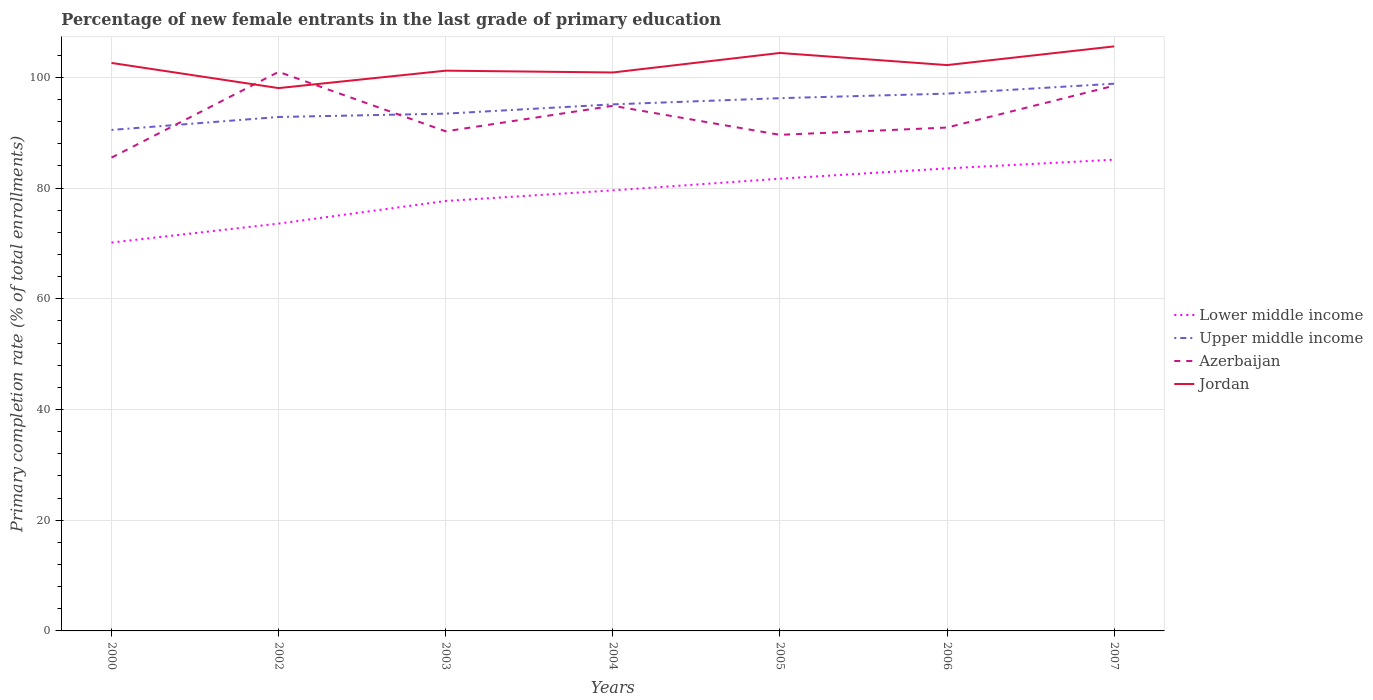Is the number of lines equal to the number of legend labels?
Your response must be concise. Yes. Across all years, what is the maximum percentage of new female entrants in Jordan?
Your response must be concise. 98.06. What is the total percentage of new female entrants in Jordan in the graph?
Provide a short and direct response. -4.16. What is the difference between the highest and the second highest percentage of new female entrants in Jordan?
Keep it short and to the point. 7.54. What is the difference between the highest and the lowest percentage of new female entrants in Jordan?
Your response must be concise. 4. Is the percentage of new female entrants in Lower middle income strictly greater than the percentage of new female entrants in Upper middle income over the years?
Your answer should be compact. Yes. How many lines are there?
Provide a short and direct response. 4. What is the difference between two consecutive major ticks on the Y-axis?
Give a very brief answer. 20. Are the values on the major ticks of Y-axis written in scientific E-notation?
Make the answer very short. No. Where does the legend appear in the graph?
Ensure brevity in your answer.  Center right. How are the legend labels stacked?
Your answer should be compact. Vertical. What is the title of the graph?
Your response must be concise. Percentage of new female entrants in the last grade of primary education. What is the label or title of the Y-axis?
Make the answer very short. Primary completion rate (% of total enrollments). What is the Primary completion rate (% of total enrollments) of Lower middle income in 2000?
Ensure brevity in your answer.  70.16. What is the Primary completion rate (% of total enrollments) of Upper middle income in 2000?
Offer a very short reply. 90.5. What is the Primary completion rate (% of total enrollments) in Azerbaijan in 2000?
Your answer should be compact. 85.5. What is the Primary completion rate (% of total enrollments) of Jordan in 2000?
Give a very brief answer. 102.6. What is the Primary completion rate (% of total enrollments) of Lower middle income in 2002?
Ensure brevity in your answer.  73.58. What is the Primary completion rate (% of total enrollments) of Upper middle income in 2002?
Your response must be concise. 92.84. What is the Primary completion rate (% of total enrollments) of Azerbaijan in 2002?
Your answer should be compact. 100.99. What is the Primary completion rate (% of total enrollments) of Jordan in 2002?
Provide a short and direct response. 98.06. What is the Primary completion rate (% of total enrollments) in Lower middle income in 2003?
Give a very brief answer. 77.67. What is the Primary completion rate (% of total enrollments) in Upper middle income in 2003?
Make the answer very short. 93.44. What is the Primary completion rate (% of total enrollments) of Azerbaijan in 2003?
Offer a terse response. 90.25. What is the Primary completion rate (% of total enrollments) in Jordan in 2003?
Your answer should be compact. 101.21. What is the Primary completion rate (% of total enrollments) in Lower middle income in 2004?
Give a very brief answer. 79.58. What is the Primary completion rate (% of total enrollments) in Upper middle income in 2004?
Give a very brief answer. 95.12. What is the Primary completion rate (% of total enrollments) in Azerbaijan in 2004?
Make the answer very short. 94.86. What is the Primary completion rate (% of total enrollments) of Jordan in 2004?
Your answer should be very brief. 100.88. What is the Primary completion rate (% of total enrollments) of Lower middle income in 2005?
Make the answer very short. 81.69. What is the Primary completion rate (% of total enrollments) in Upper middle income in 2005?
Your answer should be very brief. 96.24. What is the Primary completion rate (% of total enrollments) of Azerbaijan in 2005?
Your response must be concise. 89.61. What is the Primary completion rate (% of total enrollments) of Jordan in 2005?
Your answer should be compact. 104.4. What is the Primary completion rate (% of total enrollments) in Lower middle income in 2006?
Your answer should be compact. 83.55. What is the Primary completion rate (% of total enrollments) of Upper middle income in 2006?
Offer a very short reply. 97.06. What is the Primary completion rate (% of total enrollments) of Azerbaijan in 2006?
Give a very brief answer. 90.93. What is the Primary completion rate (% of total enrollments) in Jordan in 2006?
Give a very brief answer. 102.21. What is the Primary completion rate (% of total enrollments) of Lower middle income in 2007?
Provide a short and direct response. 85.12. What is the Primary completion rate (% of total enrollments) in Upper middle income in 2007?
Ensure brevity in your answer.  98.85. What is the Primary completion rate (% of total enrollments) in Azerbaijan in 2007?
Your answer should be compact. 98.49. What is the Primary completion rate (% of total enrollments) of Jordan in 2007?
Ensure brevity in your answer.  105.59. Across all years, what is the maximum Primary completion rate (% of total enrollments) in Lower middle income?
Your answer should be compact. 85.12. Across all years, what is the maximum Primary completion rate (% of total enrollments) of Upper middle income?
Your response must be concise. 98.85. Across all years, what is the maximum Primary completion rate (% of total enrollments) of Azerbaijan?
Offer a terse response. 100.99. Across all years, what is the maximum Primary completion rate (% of total enrollments) of Jordan?
Offer a terse response. 105.59. Across all years, what is the minimum Primary completion rate (% of total enrollments) in Lower middle income?
Give a very brief answer. 70.16. Across all years, what is the minimum Primary completion rate (% of total enrollments) in Upper middle income?
Provide a short and direct response. 90.5. Across all years, what is the minimum Primary completion rate (% of total enrollments) in Azerbaijan?
Your answer should be compact. 85.5. Across all years, what is the minimum Primary completion rate (% of total enrollments) of Jordan?
Your response must be concise. 98.06. What is the total Primary completion rate (% of total enrollments) in Lower middle income in the graph?
Your answer should be compact. 551.36. What is the total Primary completion rate (% of total enrollments) of Upper middle income in the graph?
Your response must be concise. 664.05. What is the total Primary completion rate (% of total enrollments) in Azerbaijan in the graph?
Your response must be concise. 650.63. What is the total Primary completion rate (% of total enrollments) in Jordan in the graph?
Provide a succinct answer. 714.95. What is the difference between the Primary completion rate (% of total enrollments) of Lower middle income in 2000 and that in 2002?
Make the answer very short. -3.42. What is the difference between the Primary completion rate (% of total enrollments) in Upper middle income in 2000 and that in 2002?
Your answer should be compact. -2.34. What is the difference between the Primary completion rate (% of total enrollments) in Azerbaijan in 2000 and that in 2002?
Keep it short and to the point. -15.49. What is the difference between the Primary completion rate (% of total enrollments) of Jordan in 2000 and that in 2002?
Your answer should be compact. 4.54. What is the difference between the Primary completion rate (% of total enrollments) in Lower middle income in 2000 and that in 2003?
Provide a short and direct response. -7.51. What is the difference between the Primary completion rate (% of total enrollments) in Upper middle income in 2000 and that in 2003?
Provide a succinct answer. -2.94. What is the difference between the Primary completion rate (% of total enrollments) of Azerbaijan in 2000 and that in 2003?
Ensure brevity in your answer.  -4.75. What is the difference between the Primary completion rate (% of total enrollments) in Jordan in 2000 and that in 2003?
Offer a terse response. 1.4. What is the difference between the Primary completion rate (% of total enrollments) in Lower middle income in 2000 and that in 2004?
Ensure brevity in your answer.  -9.42. What is the difference between the Primary completion rate (% of total enrollments) of Upper middle income in 2000 and that in 2004?
Give a very brief answer. -4.62. What is the difference between the Primary completion rate (% of total enrollments) of Azerbaijan in 2000 and that in 2004?
Your answer should be very brief. -9.36. What is the difference between the Primary completion rate (% of total enrollments) of Jordan in 2000 and that in 2004?
Provide a short and direct response. 1.72. What is the difference between the Primary completion rate (% of total enrollments) in Lower middle income in 2000 and that in 2005?
Keep it short and to the point. -11.53. What is the difference between the Primary completion rate (% of total enrollments) of Upper middle income in 2000 and that in 2005?
Make the answer very short. -5.74. What is the difference between the Primary completion rate (% of total enrollments) of Azerbaijan in 2000 and that in 2005?
Provide a succinct answer. -4.12. What is the difference between the Primary completion rate (% of total enrollments) in Jordan in 2000 and that in 2005?
Offer a very short reply. -1.8. What is the difference between the Primary completion rate (% of total enrollments) in Lower middle income in 2000 and that in 2006?
Ensure brevity in your answer.  -13.39. What is the difference between the Primary completion rate (% of total enrollments) of Upper middle income in 2000 and that in 2006?
Provide a succinct answer. -6.56. What is the difference between the Primary completion rate (% of total enrollments) in Azerbaijan in 2000 and that in 2006?
Provide a succinct answer. -5.43. What is the difference between the Primary completion rate (% of total enrollments) of Jordan in 2000 and that in 2006?
Offer a terse response. 0.39. What is the difference between the Primary completion rate (% of total enrollments) in Lower middle income in 2000 and that in 2007?
Your response must be concise. -14.96. What is the difference between the Primary completion rate (% of total enrollments) of Upper middle income in 2000 and that in 2007?
Your answer should be compact. -8.35. What is the difference between the Primary completion rate (% of total enrollments) in Azerbaijan in 2000 and that in 2007?
Your response must be concise. -12.99. What is the difference between the Primary completion rate (% of total enrollments) in Jordan in 2000 and that in 2007?
Your answer should be compact. -2.99. What is the difference between the Primary completion rate (% of total enrollments) of Lower middle income in 2002 and that in 2003?
Offer a terse response. -4.08. What is the difference between the Primary completion rate (% of total enrollments) in Upper middle income in 2002 and that in 2003?
Make the answer very short. -0.6. What is the difference between the Primary completion rate (% of total enrollments) in Azerbaijan in 2002 and that in 2003?
Give a very brief answer. 10.74. What is the difference between the Primary completion rate (% of total enrollments) of Jordan in 2002 and that in 2003?
Make the answer very short. -3.15. What is the difference between the Primary completion rate (% of total enrollments) in Lower middle income in 2002 and that in 2004?
Your answer should be compact. -6. What is the difference between the Primary completion rate (% of total enrollments) of Upper middle income in 2002 and that in 2004?
Keep it short and to the point. -2.28. What is the difference between the Primary completion rate (% of total enrollments) in Azerbaijan in 2002 and that in 2004?
Make the answer very short. 6.13. What is the difference between the Primary completion rate (% of total enrollments) in Jordan in 2002 and that in 2004?
Offer a terse response. -2.82. What is the difference between the Primary completion rate (% of total enrollments) in Lower middle income in 2002 and that in 2005?
Your answer should be very brief. -8.11. What is the difference between the Primary completion rate (% of total enrollments) in Upper middle income in 2002 and that in 2005?
Give a very brief answer. -3.4. What is the difference between the Primary completion rate (% of total enrollments) of Azerbaijan in 2002 and that in 2005?
Make the answer very short. 11.38. What is the difference between the Primary completion rate (% of total enrollments) in Jordan in 2002 and that in 2005?
Offer a very short reply. -6.35. What is the difference between the Primary completion rate (% of total enrollments) of Lower middle income in 2002 and that in 2006?
Provide a short and direct response. -9.97. What is the difference between the Primary completion rate (% of total enrollments) of Upper middle income in 2002 and that in 2006?
Your answer should be very brief. -4.22. What is the difference between the Primary completion rate (% of total enrollments) in Azerbaijan in 2002 and that in 2006?
Offer a terse response. 10.06. What is the difference between the Primary completion rate (% of total enrollments) of Jordan in 2002 and that in 2006?
Make the answer very short. -4.16. What is the difference between the Primary completion rate (% of total enrollments) of Lower middle income in 2002 and that in 2007?
Provide a short and direct response. -11.54. What is the difference between the Primary completion rate (% of total enrollments) of Upper middle income in 2002 and that in 2007?
Your answer should be compact. -6.01. What is the difference between the Primary completion rate (% of total enrollments) of Azerbaijan in 2002 and that in 2007?
Provide a short and direct response. 2.5. What is the difference between the Primary completion rate (% of total enrollments) in Jordan in 2002 and that in 2007?
Offer a terse response. -7.54. What is the difference between the Primary completion rate (% of total enrollments) of Lower middle income in 2003 and that in 2004?
Keep it short and to the point. -1.92. What is the difference between the Primary completion rate (% of total enrollments) of Upper middle income in 2003 and that in 2004?
Offer a terse response. -1.68. What is the difference between the Primary completion rate (% of total enrollments) in Azerbaijan in 2003 and that in 2004?
Ensure brevity in your answer.  -4.61. What is the difference between the Primary completion rate (% of total enrollments) in Jordan in 2003 and that in 2004?
Give a very brief answer. 0.33. What is the difference between the Primary completion rate (% of total enrollments) in Lower middle income in 2003 and that in 2005?
Provide a short and direct response. -4.03. What is the difference between the Primary completion rate (% of total enrollments) in Upper middle income in 2003 and that in 2005?
Ensure brevity in your answer.  -2.8. What is the difference between the Primary completion rate (% of total enrollments) in Azerbaijan in 2003 and that in 2005?
Your answer should be very brief. 0.64. What is the difference between the Primary completion rate (% of total enrollments) of Jordan in 2003 and that in 2005?
Your answer should be very brief. -3.2. What is the difference between the Primary completion rate (% of total enrollments) of Lower middle income in 2003 and that in 2006?
Give a very brief answer. -5.89. What is the difference between the Primary completion rate (% of total enrollments) of Upper middle income in 2003 and that in 2006?
Provide a short and direct response. -3.62. What is the difference between the Primary completion rate (% of total enrollments) of Azerbaijan in 2003 and that in 2006?
Offer a terse response. -0.68. What is the difference between the Primary completion rate (% of total enrollments) in Jordan in 2003 and that in 2006?
Make the answer very short. -1.01. What is the difference between the Primary completion rate (% of total enrollments) in Lower middle income in 2003 and that in 2007?
Make the answer very short. -7.46. What is the difference between the Primary completion rate (% of total enrollments) in Upper middle income in 2003 and that in 2007?
Offer a terse response. -5.41. What is the difference between the Primary completion rate (% of total enrollments) of Azerbaijan in 2003 and that in 2007?
Provide a short and direct response. -8.24. What is the difference between the Primary completion rate (% of total enrollments) in Jordan in 2003 and that in 2007?
Make the answer very short. -4.39. What is the difference between the Primary completion rate (% of total enrollments) of Lower middle income in 2004 and that in 2005?
Make the answer very short. -2.11. What is the difference between the Primary completion rate (% of total enrollments) of Upper middle income in 2004 and that in 2005?
Make the answer very short. -1.12. What is the difference between the Primary completion rate (% of total enrollments) in Azerbaijan in 2004 and that in 2005?
Ensure brevity in your answer.  5.24. What is the difference between the Primary completion rate (% of total enrollments) of Jordan in 2004 and that in 2005?
Your answer should be very brief. -3.52. What is the difference between the Primary completion rate (% of total enrollments) of Lower middle income in 2004 and that in 2006?
Offer a terse response. -3.97. What is the difference between the Primary completion rate (% of total enrollments) in Upper middle income in 2004 and that in 2006?
Make the answer very short. -1.94. What is the difference between the Primary completion rate (% of total enrollments) in Azerbaijan in 2004 and that in 2006?
Provide a short and direct response. 3.93. What is the difference between the Primary completion rate (% of total enrollments) in Jordan in 2004 and that in 2006?
Make the answer very short. -1.33. What is the difference between the Primary completion rate (% of total enrollments) of Lower middle income in 2004 and that in 2007?
Offer a very short reply. -5.54. What is the difference between the Primary completion rate (% of total enrollments) of Upper middle income in 2004 and that in 2007?
Ensure brevity in your answer.  -3.73. What is the difference between the Primary completion rate (% of total enrollments) of Azerbaijan in 2004 and that in 2007?
Provide a succinct answer. -3.63. What is the difference between the Primary completion rate (% of total enrollments) in Jordan in 2004 and that in 2007?
Your answer should be compact. -4.71. What is the difference between the Primary completion rate (% of total enrollments) of Lower middle income in 2005 and that in 2006?
Keep it short and to the point. -1.86. What is the difference between the Primary completion rate (% of total enrollments) of Upper middle income in 2005 and that in 2006?
Your response must be concise. -0.82. What is the difference between the Primary completion rate (% of total enrollments) of Azerbaijan in 2005 and that in 2006?
Your answer should be very brief. -1.32. What is the difference between the Primary completion rate (% of total enrollments) of Jordan in 2005 and that in 2006?
Offer a terse response. 2.19. What is the difference between the Primary completion rate (% of total enrollments) in Lower middle income in 2005 and that in 2007?
Offer a very short reply. -3.43. What is the difference between the Primary completion rate (% of total enrollments) of Upper middle income in 2005 and that in 2007?
Offer a very short reply. -2.62. What is the difference between the Primary completion rate (% of total enrollments) of Azerbaijan in 2005 and that in 2007?
Make the answer very short. -8.88. What is the difference between the Primary completion rate (% of total enrollments) of Jordan in 2005 and that in 2007?
Provide a succinct answer. -1.19. What is the difference between the Primary completion rate (% of total enrollments) of Lower middle income in 2006 and that in 2007?
Give a very brief answer. -1.57. What is the difference between the Primary completion rate (% of total enrollments) in Upper middle income in 2006 and that in 2007?
Offer a terse response. -1.79. What is the difference between the Primary completion rate (% of total enrollments) in Azerbaijan in 2006 and that in 2007?
Offer a very short reply. -7.56. What is the difference between the Primary completion rate (% of total enrollments) in Jordan in 2006 and that in 2007?
Keep it short and to the point. -3.38. What is the difference between the Primary completion rate (% of total enrollments) of Lower middle income in 2000 and the Primary completion rate (% of total enrollments) of Upper middle income in 2002?
Offer a terse response. -22.68. What is the difference between the Primary completion rate (% of total enrollments) in Lower middle income in 2000 and the Primary completion rate (% of total enrollments) in Azerbaijan in 2002?
Provide a succinct answer. -30.83. What is the difference between the Primary completion rate (% of total enrollments) in Lower middle income in 2000 and the Primary completion rate (% of total enrollments) in Jordan in 2002?
Your response must be concise. -27.9. What is the difference between the Primary completion rate (% of total enrollments) in Upper middle income in 2000 and the Primary completion rate (% of total enrollments) in Azerbaijan in 2002?
Make the answer very short. -10.49. What is the difference between the Primary completion rate (% of total enrollments) of Upper middle income in 2000 and the Primary completion rate (% of total enrollments) of Jordan in 2002?
Your answer should be very brief. -7.56. What is the difference between the Primary completion rate (% of total enrollments) of Azerbaijan in 2000 and the Primary completion rate (% of total enrollments) of Jordan in 2002?
Your answer should be compact. -12.56. What is the difference between the Primary completion rate (% of total enrollments) in Lower middle income in 2000 and the Primary completion rate (% of total enrollments) in Upper middle income in 2003?
Give a very brief answer. -23.28. What is the difference between the Primary completion rate (% of total enrollments) of Lower middle income in 2000 and the Primary completion rate (% of total enrollments) of Azerbaijan in 2003?
Your answer should be very brief. -20.09. What is the difference between the Primary completion rate (% of total enrollments) in Lower middle income in 2000 and the Primary completion rate (% of total enrollments) in Jordan in 2003?
Provide a succinct answer. -31.05. What is the difference between the Primary completion rate (% of total enrollments) of Upper middle income in 2000 and the Primary completion rate (% of total enrollments) of Azerbaijan in 2003?
Give a very brief answer. 0.25. What is the difference between the Primary completion rate (% of total enrollments) of Upper middle income in 2000 and the Primary completion rate (% of total enrollments) of Jordan in 2003?
Offer a very short reply. -10.71. What is the difference between the Primary completion rate (% of total enrollments) of Azerbaijan in 2000 and the Primary completion rate (% of total enrollments) of Jordan in 2003?
Offer a very short reply. -15.71. What is the difference between the Primary completion rate (% of total enrollments) of Lower middle income in 2000 and the Primary completion rate (% of total enrollments) of Upper middle income in 2004?
Your answer should be compact. -24.96. What is the difference between the Primary completion rate (% of total enrollments) in Lower middle income in 2000 and the Primary completion rate (% of total enrollments) in Azerbaijan in 2004?
Offer a terse response. -24.7. What is the difference between the Primary completion rate (% of total enrollments) of Lower middle income in 2000 and the Primary completion rate (% of total enrollments) of Jordan in 2004?
Your response must be concise. -30.72. What is the difference between the Primary completion rate (% of total enrollments) of Upper middle income in 2000 and the Primary completion rate (% of total enrollments) of Azerbaijan in 2004?
Provide a succinct answer. -4.36. What is the difference between the Primary completion rate (% of total enrollments) in Upper middle income in 2000 and the Primary completion rate (% of total enrollments) in Jordan in 2004?
Keep it short and to the point. -10.38. What is the difference between the Primary completion rate (% of total enrollments) of Azerbaijan in 2000 and the Primary completion rate (% of total enrollments) of Jordan in 2004?
Offer a terse response. -15.38. What is the difference between the Primary completion rate (% of total enrollments) of Lower middle income in 2000 and the Primary completion rate (% of total enrollments) of Upper middle income in 2005?
Keep it short and to the point. -26.08. What is the difference between the Primary completion rate (% of total enrollments) of Lower middle income in 2000 and the Primary completion rate (% of total enrollments) of Azerbaijan in 2005?
Make the answer very short. -19.45. What is the difference between the Primary completion rate (% of total enrollments) in Lower middle income in 2000 and the Primary completion rate (% of total enrollments) in Jordan in 2005?
Your answer should be compact. -34.24. What is the difference between the Primary completion rate (% of total enrollments) in Upper middle income in 2000 and the Primary completion rate (% of total enrollments) in Azerbaijan in 2005?
Give a very brief answer. 0.89. What is the difference between the Primary completion rate (% of total enrollments) in Upper middle income in 2000 and the Primary completion rate (% of total enrollments) in Jordan in 2005?
Ensure brevity in your answer.  -13.9. What is the difference between the Primary completion rate (% of total enrollments) in Azerbaijan in 2000 and the Primary completion rate (% of total enrollments) in Jordan in 2005?
Offer a very short reply. -18.91. What is the difference between the Primary completion rate (% of total enrollments) of Lower middle income in 2000 and the Primary completion rate (% of total enrollments) of Upper middle income in 2006?
Give a very brief answer. -26.9. What is the difference between the Primary completion rate (% of total enrollments) in Lower middle income in 2000 and the Primary completion rate (% of total enrollments) in Azerbaijan in 2006?
Offer a very short reply. -20.77. What is the difference between the Primary completion rate (% of total enrollments) of Lower middle income in 2000 and the Primary completion rate (% of total enrollments) of Jordan in 2006?
Your response must be concise. -32.05. What is the difference between the Primary completion rate (% of total enrollments) in Upper middle income in 2000 and the Primary completion rate (% of total enrollments) in Azerbaijan in 2006?
Provide a succinct answer. -0.43. What is the difference between the Primary completion rate (% of total enrollments) in Upper middle income in 2000 and the Primary completion rate (% of total enrollments) in Jordan in 2006?
Give a very brief answer. -11.71. What is the difference between the Primary completion rate (% of total enrollments) in Azerbaijan in 2000 and the Primary completion rate (% of total enrollments) in Jordan in 2006?
Provide a succinct answer. -16.72. What is the difference between the Primary completion rate (% of total enrollments) in Lower middle income in 2000 and the Primary completion rate (% of total enrollments) in Upper middle income in 2007?
Provide a succinct answer. -28.69. What is the difference between the Primary completion rate (% of total enrollments) of Lower middle income in 2000 and the Primary completion rate (% of total enrollments) of Azerbaijan in 2007?
Make the answer very short. -28.33. What is the difference between the Primary completion rate (% of total enrollments) of Lower middle income in 2000 and the Primary completion rate (% of total enrollments) of Jordan in 2007?
Your response must be concise. -35.43. What is the difference between the Primary completion rate (% of total enrollments) of Upper middle income in 2000 and the Primary completion rate (% of total enrollments) of Azerbaijan in 2007?
Ensure brevity in your answer.  -7.99. What is the difference between the Primary completion rate (% of total enrollments) of Upper middle income in 2000 and the Primary completion rate (% of total enrollments) of Jordan in 2007?
Give a very brief answer. -15.09. What is the difference between the Primary completion rate (% of total enrollments) of Azerbaijan in 2000 and the Primary completion rate (% of total enrollments) of Jordan in 2007?
Make the answer very short. -20.09. What is the difference between the Primary completion rate (% of total enrollments) of Lower middle income in 2002 and the Primary completion rate (% of total enrollments) of Upper middle income in 2003?
Make the answer very short. -19.86. What is the difference between the Primary completion rate (% of total enrollments) in Lower middle income in 2002 and the Primary completion rate (% of total enrollments) in Azerbaijan in 2003?
Keep it short and to the point. -16.67. What is the difference between the Primary completion rate (% of total enrollments) of Lower middle income in 2002 and the Primary completion rate (% of total enrollments) of Jordan in 2003?
Your answer should be compact. -27.63. What is the difference between the Primary completion rate (% of total enrollments) of Upper middle income in 2002 and the Primary completion rate (% of total enrollments) of Azerbaijan in 2003?
Give a very brief answer. 2.59. What is the difference between the Primary completion rate (% of total enrollments) of Upper middle income in 2002 and the Primary completion rate (% of total enrollments) of Jordan in 2003?
Provide a short and direct response. -8.37. What is the difference between the Primary completion rate (% of total enrollments) in Azerbaijan in 2002 and the Primary completion rate (% of total enrollments) in Jordan in 2003?
Offer a very short reply. -0.22. What is the difference between the Primary completion rate (% of total enrollments) of Lower middle income in 2002 and the Primary completion rate (% of total enrollments) of Upper middle income in 2004?
Offer a terse response. -21.54. What is the difference between the Primary completion rate (% of total enrollments) of Lower middle income in 2002 and the Primary completion rate (% of total enrollments) of Azerbaijan in 2004?
Make the answer very short. -21.28. What is the difference between the Primary completion rate (% of total enrollments) in Lower middle income in 2002 and the Primary completion rate (% of total enrollments) in Jordan in 2004?
Offer a very short reply. -27.3. What is the difference between the Primary completion rate (% of total enrollments) in Upper middle income in 2002 and the Primary completion rate (% of total enrollments) in Azerbaijan in 2004?
Your answer should be very brief. -2.02. What is the difference between the Primary completion rate (% of total enrollments) in Upper middle income in 2002 and the Primary completion rate (% of total enrollments) in Jordan in 2004?
Offer a very short reply. -8.04. What is the difference between the Primary completion rate (% of total enrollments) in Azerbaijan in 2002 and the Primary completion rate (% of total enrollments) in Jordan in 2004?
Offer a terse response. 0.11. What is the difference between the Primary completion rate (% of total enrollments) in Lower middle income in 2002 and the Primary completion rate (% of total enrollments) in Upper middle income in 2005?
Offer a very short reply. -22.66. What is the difference between the Primary completion rate (% of total enrollments) of Lower middle income in 2002 and the Primary completion rate (% of total enrollments) of Azerbaijan in 2005?
Give a very brief answer. -16.03. What is the difference between the Primary completion rate (% of total enrollments) in Lower middle income in 2002 and the Primary completion rate (% of total enrollments) in Jordan in 2005?
Give a very brief answer. -30.82. What is the difference between the Primary completion rate (% of total enrollments) in Upper middle income in 2002 and the Primary completion rate (% of total enrollments) in Azerbaijan in 2005?
Offer a very short reply. 3.23. What is the difference between the Primary completion rate (% of total enrollments) in Upper middle income in 2002 and the Primary completion rate (% of total enrollments) in Jordan in 2005?
Your answer should be very brief. -11.56. What is the difference between the Primary completion rate (% of total enrollments) of Azerbaijan in 2002 and the Primary completion rate (% of total enrollments) of Jordan in 2005?
Ensure brevity in your answer.  -3.41. What is the difference between the Primary completion rate (% of total enrollments) of Lower middle income in 2002 and the Primary completion rate (% of total enrollments) of Upper middle income in 2006?
Your answer should be very brief. -23.48. What is the difference between the Primary completion rate (% of total enrollments) in Lower middle income in 2002 and the Primary completion rate (% of total enrollments) in Azerbaijan in 2006?
Make the answer very short. -17.35. What is the difference between the Primary completion rate (% of total enrollments) in Lower middle income in 2002 and the Primary completion rate (% of total enrollments) in Jordan in 2006?
Offer a terse response. -28.63. What is the difference between the Primary completion rate (% of total enrollments) of Upper middle income in 2002 and the Primary completion rate (% of total enrollments) of Azerbaijan in 2006?
Offer a terse response. 1.91. What is the difference between the Primary completion rate (% of total enrollments) in Upper middle income in 2002 and the Primary completion rate (% of total enrollments) in Jordan in 2006?
Your answer should be compact. -9.37. What is the difference between the Primary completion rate (% of total enrollments) in Azerbaijan in 2002 and the Primary completion rate (% of total enrollments) in Jordan in 2006?
Offer a terse response. -1.22. What is the difference between the Primary completion rate (% of total enrollments) of Lower middle income in 2002 and the Primary completion rate (% of total enrollments) of Upper middle income in 2007?
Make the answer very short. -25.27. What is the difference between the Primary completion rate (% of total enrollments) in Lower middle income in 2002 and the Primary completion rate (% of total enrollments) in Azerbaijan in 2007?
Your response must be concise. -24.91. What is the difference between the Primary completion rate (% of total enrollments) in Lower middle income in 2002 and the Primary completion rate (% of total enrollments) in Jordan in 2007?
Your answer should be compact. -32.01. What is the difference between the Primary completion rate (% of total enrollments) in Upper middle income in 2002 and the Primary completion rate (% of total enrollments) in Azerbaijan in 2007?
Keep it short and to the point. -5.65. What is the difference between the Primary completion rate (% of total enrollments) of Upper middle income in 2002 and the Primary completion rate (% of total enrollments) of Jordan in 2007?
Provide a succinct answer. -12.75. What is the difference between the Primary completion rate (% of total enrollments) of Azerbaijan in 2002 and the Primary completion rate (% of total enrollments) of Jordan in 2007?
Make the answer very short. -4.6. What is the difference between the Primary completion rate (% of total enrollments) in Lower middle income in 2003 and the Primary completion rate (% of total enrollments) in Upper middle income in 2004?
Your answer should be compact. -17.45. What is the difference between the Primary completion rate (% of total enrollments) of Lower middle income in 2003 and the Primary completion rate (% of total enrollments) of Azerbaijan in 2004?
Keep it short and to the point. -17.19. What is the difference between the Primary completion rate (% of total enrollments) in Lower middle income in 2003 and the Primary completion rate (% of total enrollments) in Jordan in 2004?
Your answer should be very brief. -23.21. What is the difference between the Primary completion rate (% of total enrollments) of Upper middle income in 2003 and the Primary completion rate (% of total enrollments) of Azerbaijan in 2004?
Ensure brevity in your answer.  -1.42. What is the difference between the Primary completion rate (% of total enrollments) in Upper middle income in 2003 and the Primary completion rate (% of total enrollments) in Jordan in 2004?
Give a very brief answer. -7.44. What is the difference between the Primary completion rate (% of total enrollments) in Azerbaijan in 2003 and the Primary completion rate (% of total enrollments) in Jordan in 2004?
Give a very brief answer. -10.63. What is the difference between the Primary completion rate (% of total enrollments) of Lower middle income in 2003 and the Primary completion rate (% of total enrollments) of Upper middle income in 2005?
Offer a terse response. -18.57. What is the difference between the Primary completion rate (% of total enrollments) of Lower middle income in 2003 and the Primary completion rate (% of total enrollments) of Azerbaijan in 2005?
Offer a very short reply. -11.95. What is the difference between the Primary completion rate (% of total enrollments) in Lower middle income in 2003 and the Primary completion rate (% of total enrollments) in Jordan in 2005?
Offer a terse response. -26.74. What is the difference between the Primary completion rate (% of total enrollments) of Upper middle income in 2003 and the Primary completion rate (% of total enrollments) of Azerbaijan in 2005?
Provide a succinct answer. 3.83. What is the difference between the Primary completion rate (% of total enrollments) of Upper middle income in 2003 and the Primary completion rate (% of total enrollments) of Jordan in 2005?
Your answer should be very brief. -10.96. What is the difference between the Primary completion rate (% of total enrollments) in Azerbaijan in 2003 and the Primary completion rate (% of total enrollments) in Jordan in 2005?
Provide a short and direct response. -14.15. What is the difference between the Primary completion rate (% of total enrollments) of Lower middle income in 2003 and the Primary completion rate (% of total enrollments) of Upper middle income in 2006?
Your response must be concise. -19.39. What is the difference between the Primary completion rate (% of total enrollments) of Lower middle income in 2003 and the Primary completion rate (% of total enrollments) of Azerbaijan in 2006?
Make the answer very short. -13.27. What is the difference between the Primary completion rate (% of total enrollments) of Lower middle income in 2003 and the Primary completion rate (% of total enrollments) of Jordan in 2006?
Make the answer very short. -24.55. What is the difference between the Primary completion rate (% of total enrollments) of Upper middle income in 2003 and the Primary completion rate (% of total enrollments) of Azerbaijan in 2006?
Offer a very short reply. 2.51. What is the difference between the Primary completion rate (% of total enrollments) of Upper middle income in 2003 and the Primary completion rate (% of total enrollments) of Jordan in 2006?
Offer a very short reply. -8.77. What is the difference between the Primary completion rate (% of total enrollments) in Azerbaijan in 2003 and the Primary completion rate (% of total enrollments) in Jordan in 2006?
Make the answer very short. -11.97. What is the difference between the Primary completion rate (% of total enrollments) in Lower middle income in 2003 and the Primary completion rate (% of total enrollments) in Upper middle income in 2007?
Give a very brief answer. -21.19. What is the difference between the Primary completion rate (% of total enrollments) of Lower middle income in 2003 and the Primary completion rate (% of total enrollments) of Azerbaijan in 2007?
Keep it short and to the point. -20.83. What is the difference between the Primary completion rate (% of total enrollments) in Lower middle income in 2003 and the Primary completion rate (% of total enrollments) in Jordan in 2007?
Ensure brevity in your answer.  -27.93. What is the difference between the Primary completion rate (% of total enrollments) in Upper middle income in 2003 and the Primary completion rate (% of total enrollments) in Azerbaijan in 2007?
Offer a terse response. -5.05. What is the difference between the Primary completion rate (% of total enrollments) of Upper middle income in 2003 and the Primary completion rate (% of total enrollments) of Jordan in 2007?
Your answer should be compact. -12.15. What is the difference between the Primary completion rate (% of total enrollments) in Azerbaijan in 2003 and the Primary completion rate (% of total enrollments) in Jordan in 2007?
Your response must be concise. -15.34. What is the difference between the Primary completion rate (% of total enrollments) of Lower middle income in 2004 and the Primary completion rate (% of total enrollments) of Upper middle income in 2005?
Your answer should be compact. -16.66. What is the difference between the Primary completion rate (% of total enrollments) in Lower middle income in 2004 and the Primary completion rate (% of total enrollments) in Azerbaijan in 2005?
Keep it short and to the point. -10.03. What is the difference between the Primary completion rate (% of total enrollments) in Lower middle income in 2004 and the Primary completion rate (% of total enrollments) in Jordan in 2005?
Offer a terse response. -24.82. What is the difference between the Primary completion rate (% of total enrollments) of Upper middle income in 2004 and the Primary completion rate (% of total enrollments) of Azerbaijan in 2005?
Provide a short and direct response. 5.51. What is the difference between the Primary completion rate (% of total enrollments) of Upper middle income in 2004 and the Primary completion rate (% of total enrollments) of Jordan in 2005?
Make the answer very short. -9.28. What is the difference between the Primary completion rate (% of total enrollments) in Azerbaijan in 2004 and the Primary completion rate (% of total enrollments) in Jordan in 2005?
Offer a very short reply. -9.55. What is the difference between the Primary completion rate (% of total enrollments) in Lower middle income in 2004 and the Primary completion rate (% of total enrollments) in Upper middle income in 2006?
Give a very brief answer. -17.48. What is the difference between the Primary completion rate (% of total enrollments) of Lower middle income in 2004 and the Primary completion rate (% of total enrollments) of Azerbaijan in 2006?
Provide a succinct answer. -11.35. What is the difference between the Primary completion rate (% of total enrollments) of Lower middle income in 2004 and the Primary completion rate (% of total enrollments) of Jordan in 2006?
Make the answer very short. -22.63. What is the difference between the Primary completion rate (% of total enrollments) in Upper middle income in 2004 and the Primary completion rate (% of total enrollments) in Azerbaijan in 2006?
Your answer should be compact. 4.19. What is the difference between the Primary completion rate (% of total enrollments) of Upper middle income in 2004 and the Primary completion rate (% of total enrollments) of Jordan in 2006?
Make the answer very short. -7.1. What is the difference between the Primary completion rate (% of total enrollments) of Azerbaijan in 2004 and the Primary completion rate (% of total enrollments) of Jordan in 2006?
Ensure brevity in your answer.  -7.36. What is the difference between the Primary completion rate (% of total enrollments) of Lower middle income in 2004 and the Primary completion rate (% of total enrollments) of Upper middle income in 2007?
Ensure brevity in your answer.  -19.27. What is the difference between the Primary completion rate (% of total enrollments) in Lower middle income in 2004 and the Primary completion rate (% of total enrollments) in Azerbaijan in 2007?
Your answer should be very brief. -18.91. What is the difference between the Primary completion rate (% of total enrollments) in Lower middle income in 2004 and the Primary completion rate (% of total enrollments) in Jordan in 2007?
Ensure brevity in your answer.  -26.01. What is the difference between the Primary completion rate (% of total enrollments) in Upper middle income in 2004 and the Primary completion rate (% of total enrollments) in Azerbaijan in 2007?
Ensure brevity in your answer.  -3.37. What is the difference between the Primary completion rate (% of total enrollments) of Upper middle income in 2004 and the Primary completion rate (% of total enrollments) of Jordan in 2007?
Provide a short and direct response. -10.47. What is the difference between the Primary completion rate (% of total enrollments) of Azerbaijan in 2004 and the Primary completion rate (% of total enrollments) of Jordan in 2007?
Make the answer very short. -10.73. What is the difference between the Primary completion rate (% of total enrollments) in Lower middle income in 2005 and the Primary completion rate (% of total enrollments) in Upper middle income in 2006?
Offer a terse response. -15.37. What is the difference between the Primary completion rate (% of total enrollments) of Lower middle income in 2005 and the Primary completion rate (% of total enrollments) of Azerbaijan in 2006?
Your response must be concise. -9.24. What is the difference between the Primary completion rate (% of total enrollments) of Lower middle income in 2005 and the Primary completion rate (% of total enrollments) of Jordan in 2006?
Ensure brevity in your answer.  -20.52. What is the difference between the Primary completion rate (% of total enrollments) in Upper middle income in 2005 and the Primary completion rate (% of total enrollments) in Azerbaijan in 2006?
Ensure brevity in your answer.  5.3. What is the difference between the Primary completion rate (% of total enrollments) in Upper middle income in 2005 and the Primary completion rate (% of total enrollments) in Jordan in 2006?
Keep it short and to the point. -5.98. What is the difference between the Primary completion rate (% of total enrollments) in Azerbaijan in 2005 and the Primary completion rate (% of total enrollments) in Jordan in 2006?
Make the answer very short. -12.6. What is the difference between the Primary completion rate (% of total enrollments) in Lower middle income in 2005 and the Primary completion rate (% of total enrollments) in Upper middle income in 2007?
Ensure brevity in your answer.  -17.16. What is the difference between the Primary completion rate (% of total enrollments) of Lower middle income in 2005 and the Primary completion rate (% of total enrollments) of Azerbaijan in 2007?
Your answer should be compact. -16.8. What is the difference between the Primary completion rate (% of total enrollments) of Lower middle income in 2005 and the Primary completion rate (% of total enrollments) of Jordan in 2007?
Your answer should be compact. -23.9. What is the difference between the Primary completion rate (% of total enrollments) of Upper middle income in 2005 and the Primary completion rate (% of total enrollments) of Azerbaijan in 2007?
Offer a terse response. -2.26. What is the difference between the Primary completion rate (% of total enrollments) of Upper middle income in 2005 and the Primary completion rate (% of total enrollments) of Jordan in 2007?
Your response must be concise. -9.36. What is the difference between the Primary completion rate (% of total enrollments) in Azerbaijan in 2005 and the Primary completion rate (% of total enrollments) in Jordan in 2007?
Provide a succinct answer. -15.98. What is the difference between the Primary completion rate (% of total enrollments) in Lower middle income in 2006 and the Primary completion rate (% of total enrollments) in Upper middle income in 2007?
Offer a very short reply. -15.3. What is the difference between the Primary completion rate (% of total enrollments) of Lower middle income in 2006 and the Primary completion rate (% of total enrollments) of Azerbaijan in 2007?
Offer a terse response. -14.94. What is the difference between the Primary completion rate (% of total enrollments) of Lower middle income in 2006 and the Primary completion rate (% of total enrollments) of Jordan in 2007?
Ensure brevity in your answer.  -22.04. What is the difference between the Primary completion rate (% of total enrollments) in Upper middle income in 2006 and the Primary completion rate (% of total enrollments) in Azerbaijan in 2007?
Make the answer very short. -1.43. What is the difference between the Primary completion rate (% of total enrollments) of Upper middle income in 2006 and the Primary completion rate (% of total enrollments) of Jordan in 2007?
Keep it short and to the point. -8.53. What is the difference between the Primary completion rate (% of total enrollments) of Azerbaijan in 2006 and the Primary completion rate (% of total enrollments) of Jordan in 2007?
Provide a succinct answer. -14.66. What is the average Primary completion rate (% of total enrollments) in Lower middle income per year?
Give a very brief answer. 78.77. What is the average Primary completion rate (% of total enrollments) of Upper middle income per year?
Provide a short and direct response. 94.86. What is the average Primary completion rate (% of total enrollments) of Azerbaijan per year?
Give a very brief answer. 92.95. What is the average Primary completion rate (% of total enrollments) in Jordan per year?
Offer a very short reply. 102.14. In the year 2000, what is the difference between the Primary completion rate (% of total enrollments) in Lower middle income and Primary completion rate (% of total enrollments) in Upper middle income?
Make the answer very short. -20.34. In the year 2000, what is the difference between the Primary completion rate (% of total enrollments) of Lower middle income and Primary completion rate (% of total enrollments) of Azerbaijan?
Provide a succinct answer. -15.34. In the year 2000, what is the difference between the Primary completion rate (% of total enrollments) in Lower middle income and Primary completion rate (% of total enrollments) in Jordan?
Give a very brief answer. -32.44. In the year 2000, what is the difference between the Primary completion rate (% of total enrollments) of Upper middle income and Primary completion rate (% of total enrollments) of Azerbaijan?
Make the answer very short. 5. In the year 2000, what is the difference between the Primary completion rate (% of total enrollments) of Upper middle income and Primary completion rate (% of total enrollments) of Jordan?
Keep it short and to the point. -12.1. In the year 2000, what is the difference between the Primary completion rate (% of total enrollments) of Azerbaijan and Primary completion rate (% of total enrollments) of Jordan?
Give a very brief answer. -17.1. In the year 2002, what is the difference between the Primary completion rate (% of total enrollments) of Lower middle income and Primary completion rate (% of total enrollments) of Upper middle income?
Make the answer very short. -19.26. In the year 2002, what is the difference between the Primary completion rate (% of total enrollments) of Lower middle income and Primary completion rate (% of total enrollments) of Azerbaijan?
Ensure brevity in your answer.  -27.41. In the year 2002, what is the difference between the Primary completion rate (% of total enrollments) in Lower middle income and Primary completion rate (% of total enrollments) in Jordan?
Keep it short and to the point. -24.48. In the year 2002, what is the difference between the Primary completion rate (% of total enrollments) in Upper middle income and Primary completion rate (% of total enrollments) in Azerbaijan?
Your answer should be compact. -8.15. In the year 2002, what is the difference between the Primary completion rate (% of total enrollments) of Upper middle income and Primary completion rate (% of total enrollments) of Jordan?
Your answer should be compact. -5.22. In the year 2002, what is the difference between the Primary completion rate (% of total enrollments) of Azerbaijan and Primary completion rate (% of total enrollments) of Jordan?
Offer a terse response. 2.93. In the year 2003, what is the difference between the Primary completion rate (% of total enrollments) of Lower middle income and Primary completion rate (% of total enrollments) of Upper middle income?
Your response must be concise. -15.78. In the year 2003, what is the difference between the Primary completion rate (% of total enrollments) in Lower middle income and Primary completion rate (% of total enrollments) in Azerbaijan?
Give a very brief answer. -12.58. In the year 2003, what is the difference between the Primary completion rate (% of total enrollments) in Lower middle income and Primary completion rate (% of total enrollments) in Jordan?
Your response must be concise. -23.54. In the year 2003, what is the difference between the Primary completion rate (% of total enrollments) of Upper middle income and Primary completion rate (% of total enrollments) of Azerbaijan?
Offer a very short reply. 3.19. In the year 2003, what is the difference between the Primary completion rate (% of total enrollments) in Upper middle income and Primary completion rate (% of total enrollments) in Jordan?
Provide a succinct answer. -7.77. In the year 2003, what is the difference between the Primary completion rate (% of total enrollments) of Azerbaijan and Primary completion rate (% of total enrollments) of Jordan?
Make the answer very short. -10.96. In the year 2004, what is the difference between the Primary completion rate (% of total enrollments) in Lower middle income and Primary completion rate (% of total enrollments) in Upper middle income?
Your response must be concise. -15.54. In the year 2004, what is the difference between the Primary completion rate (% of total enrollments) in Lower middle income and Primary completion rate (% of total enrollments) in Azerbaijan?
Your answer should be very brief. -15.28. In the year 2004, what is the difference between the Primary completion rate (% of total enrollments) in Lower middle income and Primary completion rate (% of total enrollments) in Jordan?
Ensure brevity in your answer.  -21.3. In the year 2004, what is the difference between the Primary completion rate (% of total enrollments) in Upper middle income and Primary completion rate (% of total enrollments) in Azerbaijan?
Make the answer very short. 0.26. In the year 2004, what is the difference between the Primary completion rate (% of total enrollments) in Upper middle income and Primary completion rate (% of total enrollments) in Jordan?
Your answer should be very brief. -5.76. In the year 2004, what is the difference between the Primary completion rate (% of total enrollments) in Azerbaijan and Primary completion rate (% of total enrollments) in Jordan?
Your response must be concise. -6.02. In the year 2005, what is the difference between the Primary completion rate (% of total enrollments) of Lower middle income and Primary completion rate (% of total enrollments) of Upper middle income?
Your answer should be compact. -14.54. In the year 2005, what is the difference between the Primary completion rate (% of total enrollments) of Lower middle income and Primary completion rate (% of total enrollments) of Azerbaijan?
Offer a very short reply. -7.92. In the year 2005, what is the difference between the Primary completion rate (% of total enrollments) in Lower middle income and Primary completion rate (% of total enrollments) in Jordan?
Offer a very short reply. -22.71. In the year 2005, what is the difference between the Primary completion rate (% of total enrollments) of Upper middle income and Primary completion rate (% of total enrollments) of Azerbaijan?
Offer a terse response. 6.62. In the year 2005, what is the difference between the Primary completion rate (% of total enrollments) in Upper middle income and Primary completion rate (% of total enrollments) in Jordan?
Your answer should be very brief. -8.17. In the year 2005, what is the difference between the Primary completion rate (% of total enrollments) in Azerbaijan and Primary completion rate (% of total enrollments) in Jordan?
Ensure brevity in your answer.  -14.79. In the year 2006, what is the difference between the Primary completion rate (% of total enrollments) in Lower middle income and Primary completion rate (% of total enrollments) in Upper middle income?
Provide a short and direct response. -13.5. In the year 2006, what is the difference between the Primary completion rate (% of total enrollments) in Lower middle income and Primary completion rate (% of total enrollments) in Azerbaijan?
Give a very brief answer. -7.38. In the year 2006, what is the difference between the Primary completion rate (% of total enrollments) of Lower middle income and Primary completion rate (% of total enrollments) of Jordan?
Offer a terse response. -18.66. In the year 2006, what is the difference between the Primary completion rate (% of total enrollments) of Upper middle income and Primary completion rate (% of total enrollments) of Azerbaijan?
Offer a very short reply. 6.13. In the year 2006, what is the difference between the Primary completion rate (% of total enrollments) in Upper middle income and Primary completion rate (% of total enrollments) in Jordan?
Your answer should be very brief. -5.16. In the year 2006, what is the difference between the Primary completion rate (% of total enrollments) of Azerbaijan and Primary completion rate (% of total enrollments) of Jordan?
Make the answer very short. -11.28. In the year 2007, what is the difference between the Primary completion rate (% of total enrollments) of Lower middle income and Primary completion rate (% of total enrollments) of Upper middle income?
Offer a very short reply. -13.73. In the year 2007, what is the difference between the Primary completion rate (% of total enrollments) in Lower middle income and Primary completion rate (% of total enrollments) in Azerbaijan?
Provide a succinct answer. -13.37. In the year 2007, what is the difference between the Primary completion rate (% of total enrollments) in Lower middle income and Primary completion rate (% of total enrollments) in Jordan?
Your response must be concise. -20.47. In the year 2007, what is the difference between the Primary completion rate (% of total enrollments) in Upper middle income and Primary completion rate (% of total enrollments) in Azerbaijan?
Make the answer very short. 0.36. In the year 2007, what is the difference between the Primary completion rate (% of total enrollments) of Upper middle income and Primary completion rate (% of total enrollments) of Jordan?
Your answer should be compact. -6.74. In the year 2007, what is the difference between the Primary completion rate (% of total enrollments) of Azerbaijan and Primary completion rate (% of total enrollments) of Jordan?
Keep it short and to the point. -7.1. What is the ratio of the Primary completion rate (% of total enrollments) in Lower middle income in 2000 to that in 2002?
Your answer should be compact. 0.95. What is the ratio of the Primary completion rate (% of total enrollments) in Upper middle income in 2000 to that in 2002?
Offer a terse response. 0.97. What is the ratio of the Primary completion rate (% of total enrollments) in Azerbaijan in 2000 to that in 2002?
Provide a short and direct response. 0.85. What is the ratio of the Primary completion rate (% of total enrollments) in Jordan in 2000 to that in 2002?
Provide a succinct answer. 1.05. What is the ratio of the Primary completion rate (% of total enrollments) in Lower middle income in 2000 to that in 2003?
Ensure brevity in your answer.  0.9. What is the ratio of the Primary completion rate (% of total enrollments) in Upper middle income in 2000 to that in 2003?
Provide a short and direct response. 0.97. What is the ratio of the Primary completion rate (% of total enrollments) in Azerbaijan in 2000 to that in 2003?
Your response must be concise. 0.95. What is the ratio of the Primary completion rate (% of total enrollments) of Jordan in 2000 to that in 2003?
Offer a terse response. 1.01. What is the ratio of the Primary completion rate (% of total enrollments) of Lower middle income in 2000 to that in 2004?
Give a very brief answer. 0.88. What is the ratio of the Primary completion rate (% of total enrollments) in Upper middle income in 2000 to that in 2004?
Your response must be concise. 0.95. What is the ratio of the Primary completion rate (% of total enrollments) of Azerbaijan in 2000 to that in 2004?
Keep it short and to the point. 0.9. What is the ratio of the Primary completion rate (% of total enrollments) in Jordan in 2000 to that in 2004?
Offer a very short reply. 1.02. What is the ratio of the Primary completion rate (% of total enrollments) in Lower middle income in 2000 to that in 2005?
Offer a very short reply. 0.86. What is the ratio of the Primary completion rate (% of total enrollments) in Upper middle income in 2000 to that in 2005?
Provide a succinct answer. 0.94. What is the ratio of the Primary completion rate (% of total enrollments) in Azerbaijan in 2000 to that in 2005?
Keep it short and to the point. 0.95. What is the ratio of the Primary completion rate (% of total enrollments) in Jordan in 2000 to that in 2005?
Ensure brevity in your answer.  0.98. What is the ratio of the Primary completion rate (% of total enrollments) in Lower middle income in 2000 to that in 2006?
Your answer should be very brief. 0.84. What is the ratio of the Primary completion rate (% of total enrollments) in Upper middle income in 2000 to that in 2006?
Offer a terse response. 0.93. What is the ratio of the Primary completion rate (% of total enrollments) in Azerbaijan in 2000 to that in 2006?
Provide a succinct answer. 0.94. What is the ratio of the Primary completion rate (% of total enrollments) of Jordan in 2000 to that in 2006?
Your response must be concise. 1. What is the ratio of the Primary completion rate (% of total enrollments) in Lower middle income in 2000 to that in 2007?
Your response must be concise. 0.82. What is the ratio of the Primary completion rate (% of total enrollments) in Upper middle income in 2000 to that in 2007?
Your response must be concise. 0.92. What is the ratio of the Primary completion rate (% of total enrollments) in Azerbaijan in 2000 to that in 2007?
Give a very brief answer. 0.87. What is the ratio of the Primary completion rate (% of total enrollments) of Jordan in 2000 to that in 2007?
Offer a terse response. 0.97. What is the ratio of the Primary completion rate (% of total enrollments) in Azerbaijan in 2002 to that in 2003?
Offer a terse response. 1.12. What is the ratio of the Primary completion rate (% of total enrollments) of Jordan in 2002 to that in 2003?
Provide a short and direct response. 0.97. What is the ratio of the Primary completion rate (% of total enrollments) of Lower middle income in 2002 to that in 2004?
Your response must be concise. 0.92. What is the ratio of the Primary completion rate (% of total enrollments) of Azerbaijan in 2002 to that in 2004?
Ensure brevity in your answer.  1.06. What is the ratio of the Primary completion rate (% of total enrollments) of Jordan in 2002 to that in 2004?
Provide a succinct answer. 0.97. What is the ratio of the Primary completion rate (% of total enrollments) in Lower middle income in 2002 to that in 2005?
Offer a terse response. 0.9. What is the ratio of the Primary completion rate (% of total enrollments) in Upper middle income in 2002 to that in 2005?
Offer a terse response. 0.96. What is the ratio of the Primary completion rate (% of total enrollments) of Azerbaijan in 2002 to that in 2005?
Ensure brevity in your answer.  1.13. What is the ratio of the Primary completion rate (% of total enrollments) of Jordan in 2002 to that in 2005?
Ensure brevity in your answer.  0.94. What is the ratio of the Primary completion rate (% of total enrollments) in Lower middle income in 2002 to that in 2006?
Keep it short and to the point. 0.88. What is the ratio of the Primary completion rate (% of total enrollments) of Upper middle income in 2002 to that in 2006?
Make the answer very short. 0.96. What is the ratio of the Primary completion rate (% of total enrollments) of Azerbaijan in 2002 to that in 2006?
Your answer should be very brief. 1.11. What is the ratio of the Primary completion rate (% of total enrollments) of Jordan in 2002 to that in 2006?
Provide a short and direct response. 0.96. What is the ratio of the Primary completion rate (% of total enrollments) of Lower middle income in 2002 to that in 2007?
Provide a short and direct response. 0.86. What is the ratio of the Primary completion rate (% of total enrollments) in Upper middle income in 2002 to that in 2007?
Keep it short and to the point. 0.94. What is the ratio of the Primary completion rate (% of total enrollments) of Azerbaijan in 2002 to that in 2007?
Ensure brevity in your answer.  1.03. What is the ratio of the Primary completion rate (% of total enrollments) in Jordan in 2002 to that in 2007?
Your answer should be compact. 0.93. What is the ratio of the Primary completion rate (% of total enrollments) in Lower middle income in 2003 to that in 2004?
Your answer should be compact. 0.98. What is the ratio of the Primary completion rate (% of total enrollments) in Upper middle income in 2003 to that in 2004?
Keep it short and to the point. 0.98. What is the ratio of the Primary completion rate (% of total enrollments) of Azerbaijan in 2003 to that in 2004?
Offer a terse response. 0.95. What is the ratio of the Primary completion rate (% of total enrollments) of Jordan in 2003 to that in 2004?
Keep it short and to the point. 1. What is the ratio of the Primary completion rate (% of total enrollments) in Lower middle income in 2003 to that in 2005?
Provide a short and direct response. 0.95. What is the ratio of the Primary completion rate (% of total enrollments) of Azerbaijan in 2003 to that in 2005?
Give a very brief answer. 1.01. What is the ratio of the Primary completion rate (% of total enrollments) of Jordan in 2003 to that in 2005?
Your response must be concise. 0.97. What is the ratio of the Primary completion rate (% of total enrollments) in Lower middle income in 2003 to that in 2006?
Provide a succinct answer. 0.93. What is the ratio of the Primary completion rate (% of total enrollments) of Upper middle income in 2003 to that in 2006?
Keep it short and to the point. 0.96. What is the ratio of the Primary completion rate (% of total enrollments) in Azerbaijan in 2003 to that in 2006?
Your answer should be compact. 0.99. What is the ratio of the Primary completion rate (% of total enrollments) in Jordan in 2003 to that in 2006?
Offer a terse response. 0.99. What is the ratio of the Primary completion rate (% of total enrollments) in Lower middle income in 2003 to that in 2007?
Make the answer very short. 0.91. What is the ratio of the Primary completion rate (% of total enrollments) in Upper middle income in 2003 to that in 2007?
Offer a very short reply. 0.95. What is the ratio of the Primary completion rate (% of total enrollments) of Azerbaijan in 2003 to that in 2007?
Offer a very short reply. 0.92. What is the ratio of the Primary completion rate (% of total enrollments) in Jordan in 2003 to that in 2007?
Your response must be concise. 0.96. What is the ratio of the Primary completion rate (% of total enrollments) in Lower middle income in 2004 to that in 2005?
Ensure brevity in your answer.  0.97. What is the ratio of the Primary completion rate (% of total enrollments) of Upper middle income in 2004 to that in 2005?
Ensure brevity in your answer.  0.99. What is the ratio of the Primary completion rate (% of total enrollments) of Azerbaijan in 2004 to that in 2005?
Provide a short and direct response. 1.06. What is the ratio of the Primary completion rate (% of total enrollments) of Jordan in 2004 to that in 2005?
Make the answer very short. 0.97. What is the ratio of the Primary completion rate (% of total enrollments) in Upper middle income in 2004 to that in 2006?
Your answer should be very brief. 0.98. What is the ratio of the Primary completion rate (% of total enrollments) of Azerbaijan in 2004 to that in 2006?
Offer a very short reply. 1.04. What is the ratio of the Primary completion rate (% of total enrollments) in Jordan in 2004 to that in 2006?
Give a very brief answer. 0.99. What is the ratio of the Primary completion rate (% of total enrollments) in Lower middle income in 2004 to that in 2007?
Your response must be concise. 0.93. What is the ratio of the Primary completion rate (% of total enrollments) in Upper middle income in 2004 to that in 2007?
Ensure brevity in your answer.  0.96. What is the ratio of the Primary completion rate (% of total enrollments) of Azerbaijan in 2004 to that in 2007?
Your answer should be very brief. 0.96. What is the ratio of the Primary completion rate (% of total enrollments) in Jordan in 2004 to that in 2007?
Your answer should be very brief. 0.96. What is the ratio of the Primary completion rate (% of total enrollments) of Lower middle income in 2005 to that in 2006?
Offer a terse response. 0.98. What is the ratio of the Primary completion rate (% of total enrollments) in Upper middle income in 2005 to that in 2006?
Keep it short and to the point. 0.99. What is the ratio of the Primary completion rate (% of total enrollments) of Azerbaijan in 2005 to that in 2006?
Keep it short and to the point. 0.99. What is the ratio of the Primary completion rate (% of total enrollments) in Jordan in 2005 to that in 2006?
Your response must be concise. 1.02. What is the ratio of the Primary completion rate (% of total enrollments) of Lower middle income in 2005 to that in 2007?
Make the answer very short. 0.96. What is the ratio of the Primary completion rate (% of total enrollments) of Upper middle income in 2005 to that in 2007?
Keep it short and to the point. 0.97. What is the ratio of the Primary completion rate (% of total enrollments) of Azerbaijan in 2005 to that in 2007?
Provide a succinct answer. 0.91. What is the ratio of the Primary completion rate (% of total enrollments) in Jordan in 2005 to that in 2007?
Your answer should be compact. 0.99. What is the ratio of the Primary completion rate (% of total enrollments) of Lower middle income in 2006 to that in 2007?
Provide a short and direct response. 0.98. What is the ratio of the Primary completion rate (% of total enrollments) in Upper middle income in 2006 to that in 2007?
Make the answer very short. 0.98. What is the ratio of the Primary completion rate (% of total enrollments) in Azerbaijan in 2006 to that in 2007?
Give a very brief answer. 0.92. What is the ratio of the Primary completion rate (% of total enrollments) of Jordan in 2006 to that in 2007?
Keep it short and to the point. 0.97. What is the difference between the highest and the second highest Primary completion rate (% of total enrollments) in Lower middle income?
Provide a short and direct response. 1.57. What is the difference between the highest and the second highest Primary completion rate (% of total enrollments) of Upper middle income?
Offer a terse response. 1.79. What is the difference between the highest and the second highest Primary completion rate (% of total enrollments) in Azerbaijan?
Ensure brevity in your answer.  2.5. What is the difference between the highest and the second highest Primary completion rate (% of total enrollments) of Jordan?
Provide a short and direct response. 1.19. What is the difference between the highest and the lowest Primary completion rate (% of total enrollments) of Lower middle income?
Offer a very short reply. 14.96. What is the difference between the highest and the lowest Primary completion rate (% of total enrollments) of Upper middle income?
Keep it short and to the point. 8.35. What is the difference between the highest and the lowest Primary completion rate (% of total enrollments) of Azerbaijan?
Offer a very short reply. 15.49. What is the difference between the highest and the lowest Primary completion rate (% of total enrollments) of Jordan?
Ensure brevity in your answer.  7.54. 